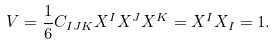Convert formula to latex. <formula><loc_0><loc_0><loc_500><loc_500>V = \frac { 1 } { 6 } C _ { I J K } X ^ { I } X ^ { J } X ^ { K } = X ^ { I } X _ { I } = 1 .</formula> 